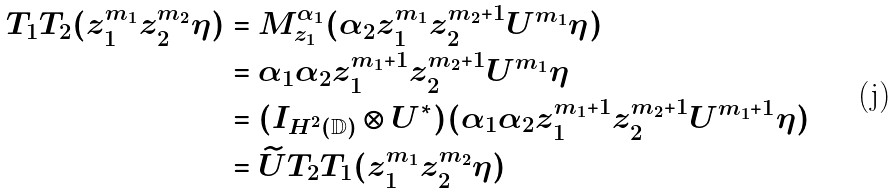Convert formula to latex. <formula><loc_0><loc_0><loc_500><loc_500>T _ { 1 } T _ { 2 } ( z _ { 1 } ^ { m _ { 1 } } z _ { 2 } ^ { m _ { 2 } } \eta ) & = M _ { z _ { 1 } } ^ { \alpha _ { 1 } } ( \alpha _ { 2 } z _ { 1 } ^ { m _ { 1 } } z _ { 2 } ^ { m _ { 2 } + 1 } U ^ { m _ { 1 } } \eta ) \\ & = \alpha _ { 1 } \alpha _ { 2 } z _ { 1 } ^ { m _ { 1 } + 1 } z _ { 2 } ^ { m _ { 2 } + 1 } U ^ { m _ { 1 } } \eta \\ & = ( I _ { H ^ { 2 } ( { \mathbb { D } } ) } \otimes U ^ { * } ) ( \alpha _ { 1 } \alpha _ { 2 } z _ { 1 } ^ { m _ { 1 } + 1 } z _ { 2 } ^ { m _ { 2 } + 1 } U ^ { m _ { 1 } + 1 } \eta ) \\ & = \widetilde { U } T _ { 2 } T _ { 1 } ( z _ { 1 } ^ { m _ { 1 } } z _ { 2 } ^ { m _ { 2 } } \eta )</formula> 